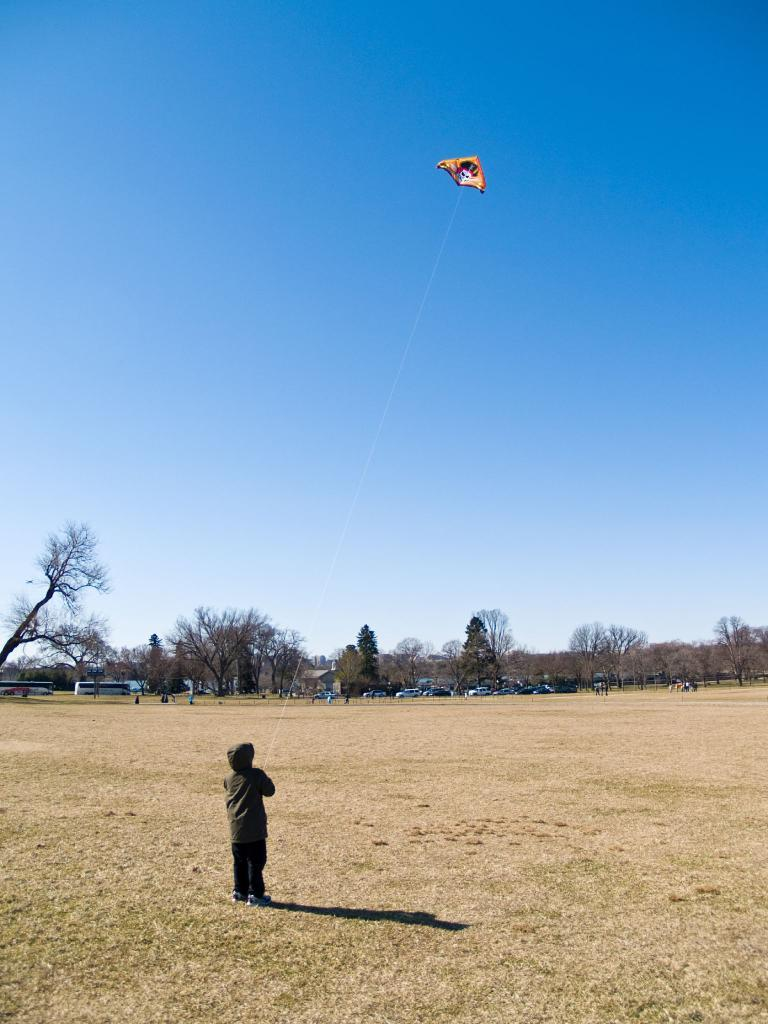Who is the main subject in the image? There is a boy in the image. What is the boy doing in the image? The boy is flying a kite. What can be seen in the background of the image? There are vehicles and trees in the background of the image. What is visible at the top of the image? The sky is visible at the top of the image. Can you see any bananas hanging from the trees in the image? There are no bananas visible in the image; only trees are present in the background. Are there any chickens running around in the image? There are no chickens present in the image; the focus is on the boy flying a kite. 